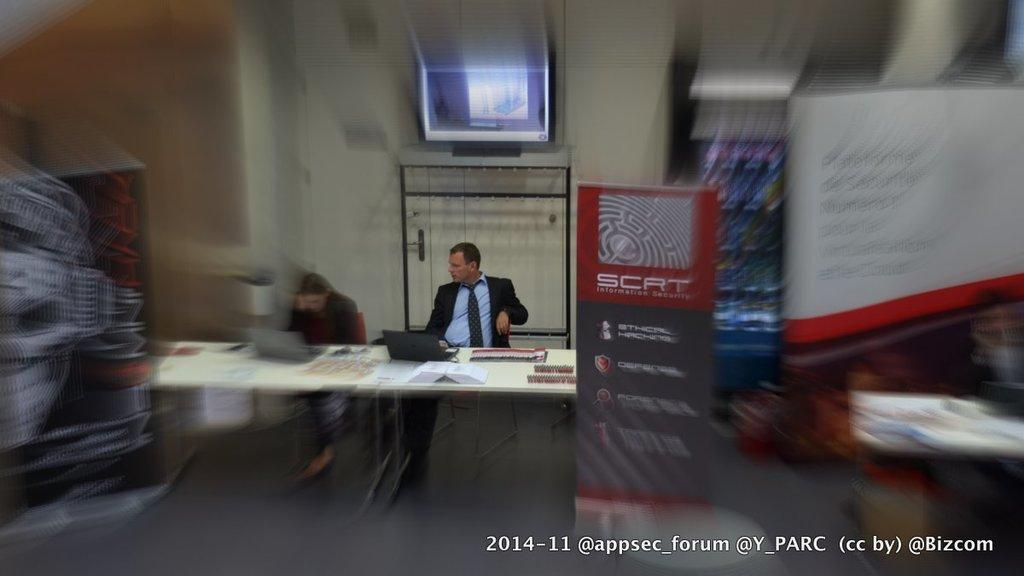Who is present in the image? There is a man and a woman in the image. What are the man and woman doing in the image? Both the man and woman are sitting on a chair. Where are the chairs located in relation to the table? The chairs are in front of a table. What can be found on the table? There are objects on the table. What additional item can be seen in the image? There is a board visible in the image. What type of debt is the man discussing with the woman in the image? There is no indication in the image that the man and woman are discussing debt or any other financial matter. 